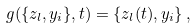Convert formula to latex. <formula><loc_0><loc_0><loc_500><loc_500>g ( \{ z _ { l } , y _ { i } \} , t ) = \{ z _ { l } ( t ) , y _ { i } \} \, ,</formula> 